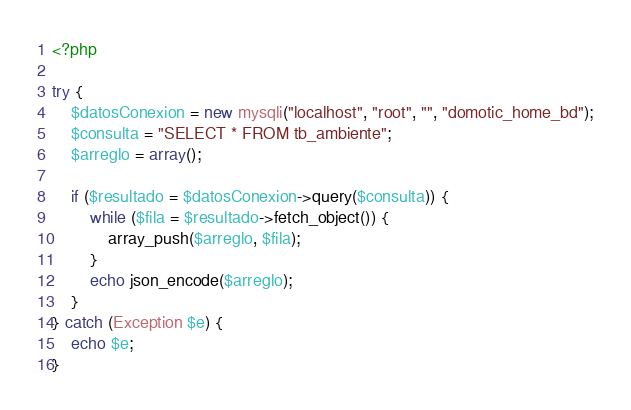Convert code to text. <code><loc_0><loc_0><loc_500><loc_500><_PHP_><?php

try {
    $datosConexion = new mysqli("localhost", "root", "", "domotic_home_bd");
    $consulta = "SELECT * FROM tb_ambiente";
    $arreglo = array();

    if ($resultado = $datosConexion->query($consulta)) {
        while ($fila = $resultado->fetch_object()) {
            array_push($arreglo, $fila);
        }
        echo json_encode($arreglo);
    }
} catch (Exception $e) {
    echo $e;
}
</code> 